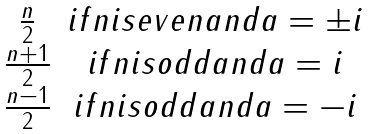<formula> <loc_0><loc_0><loc_500><loc_500>\begin{matrix} \frac { n } { 2 } & i f n i s e v e n a n d a = \pm i \\ \frac { n + 1 } { 2 } & i f n i s o d d a n d a = i \\ \frac { n - 1 } { 2 } & i f n i s o d d a n d a = - i \end{matrix}</formula> 